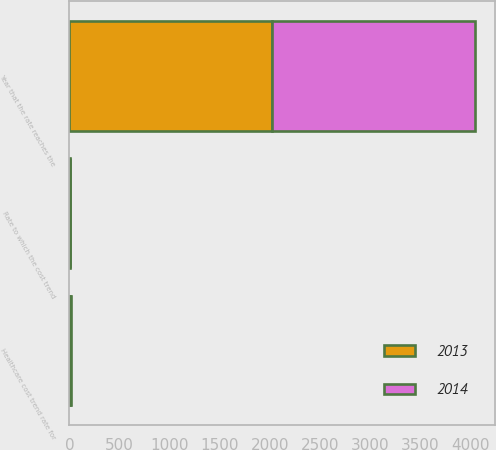Convert chart. <chart><loc_0><loc_0><loc_500><loc_500><stacked_bar_chart><ecel><fcel>Healthcare cost trend rate for<fcel>Rate to which the cost trend<fcel>Year that the rate reaches the<nl><fcel>2013<fcel>8<fcel>5<fcel>2021<nl><fcel>2014<fcel>8<fcel>5<fcel>2021<nl></chart> 